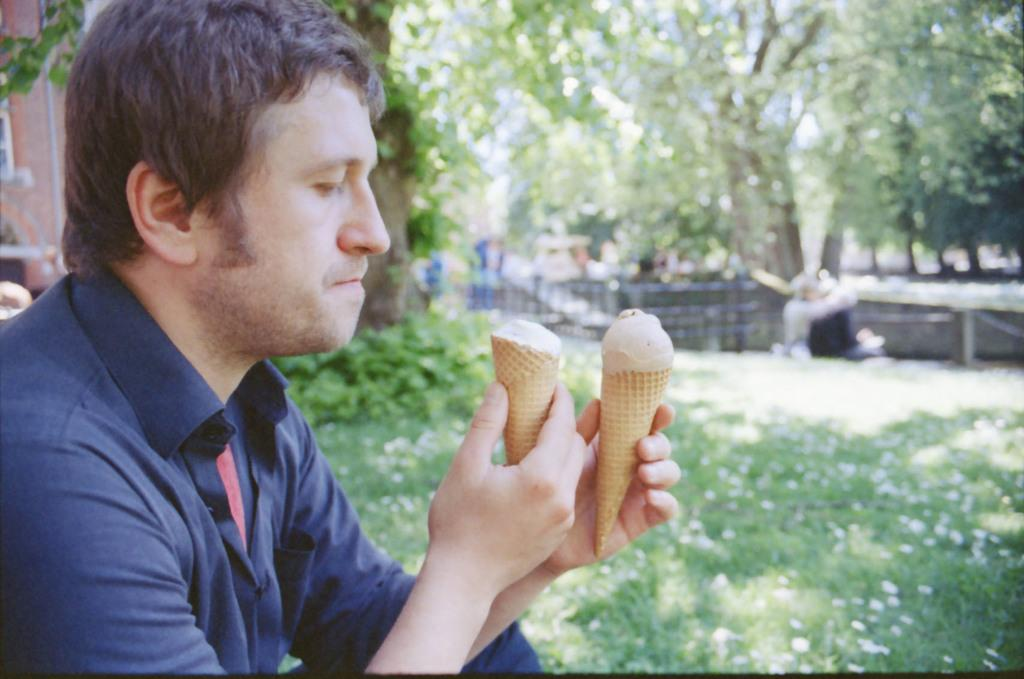What is the man in the image doing? The man is sitting in the image. What is the man holding in the image? The man is holding ice cream cones. What type of structures can be seen in the image? There are buildings visible in the image. What type of vegetation is present in the image? Trees and plants are visible in the image. What is the ground made of in the image? There is grass on the ground in the image. Where is the minister sitting in the image? There is no minister present in the image; it features a man holding ice cream cones. What type of swing can be seen in the image? There is no swing present in the image. 